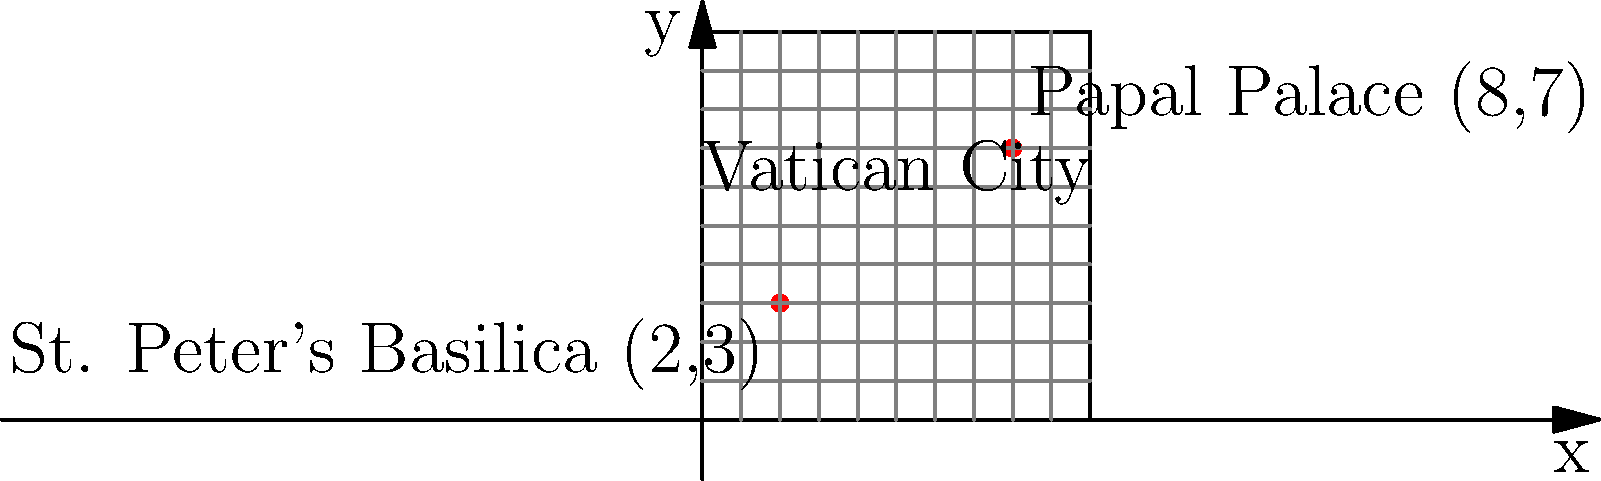Your child is serving as an altar boy in St. Peter's Basilica, located at coordinates (2,3) on the Vatican City map. You need to attend a meeting at the Papal Palace, which is at coordinates (8,7). Calculate the straight-line distance between these two locations in map units. To find the distance between two points on a Cartesian coordinate system, we can use the distance formula, which is derived from the Pythagorean theorem:

$d = \sqrt{(x_2-x_1)^2 + (y_2-y_1)^2}$

Where:
$(x_1, y_1)$ is the coordinate of the first point (St. Peter's Basilica)
$(x_2, y_2)$ is the coordinate of the second point (Papal Palace)

Let's plug in our values:
$(x_1, y_1) = (2, 3)$ (St. Peter's Basilica)
$(x_2, y_2) = (8, 7)$ (Papal Palace)

Now, let's calculate:

1) $d = \sqrt{(8-2)^2 + (7-3)^2}$

2) $d = \sqrt{6^2 + 4^2}$

3) $d = \sqrt{36 + 16}$

4) $d = \sqrt{52}$

5) $d = 2\sqrt{13} \approx 7.21$ map units

Therefore, the straight-line distance between St. Peter's Basilica and the Papal Palace is $2\sqrt{13}$ or approximately 7.21 map units.
Answer: $2\sqrt{13}$ map units 